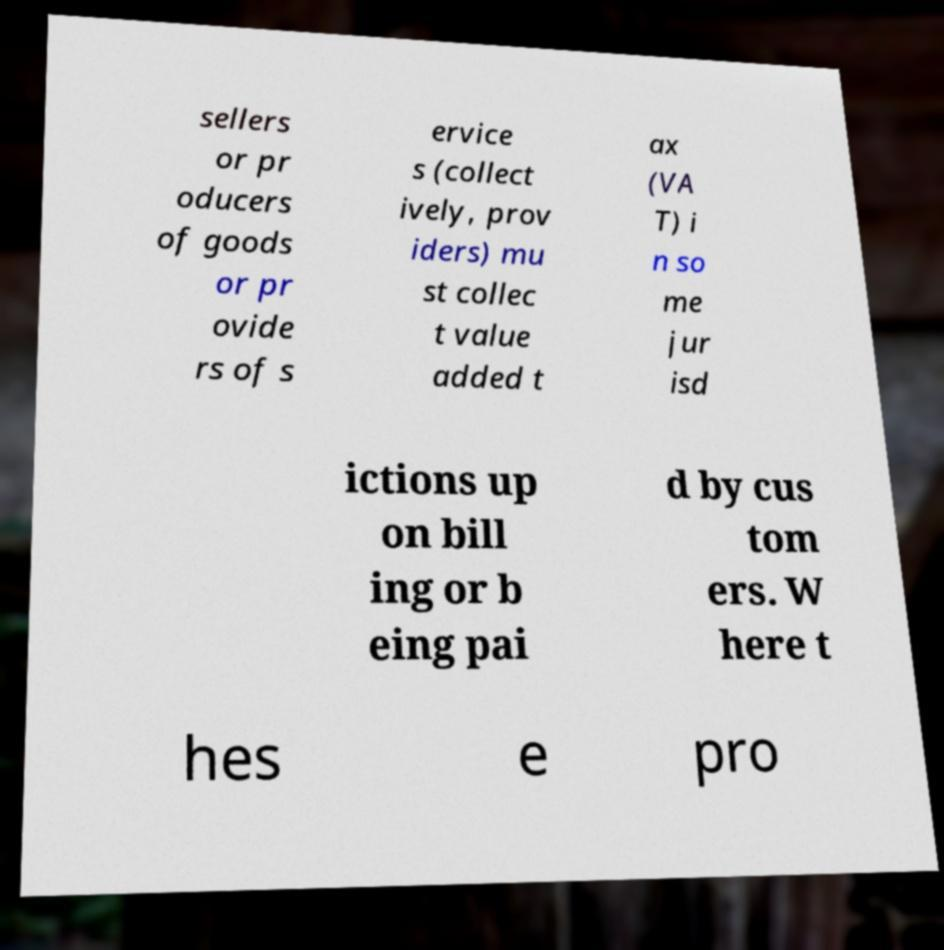For documentation purposes, I need the text within this image transcribed. Could you provide that? sellers or pr oducers of goods or pr ovide rs of s ervice s (collect ively, prov iders) mu st collec t value added t ax (VA T) i n so me jur isd ictions up on bill ing or b eing pai d by cus tom ers. W here t hes e pro 